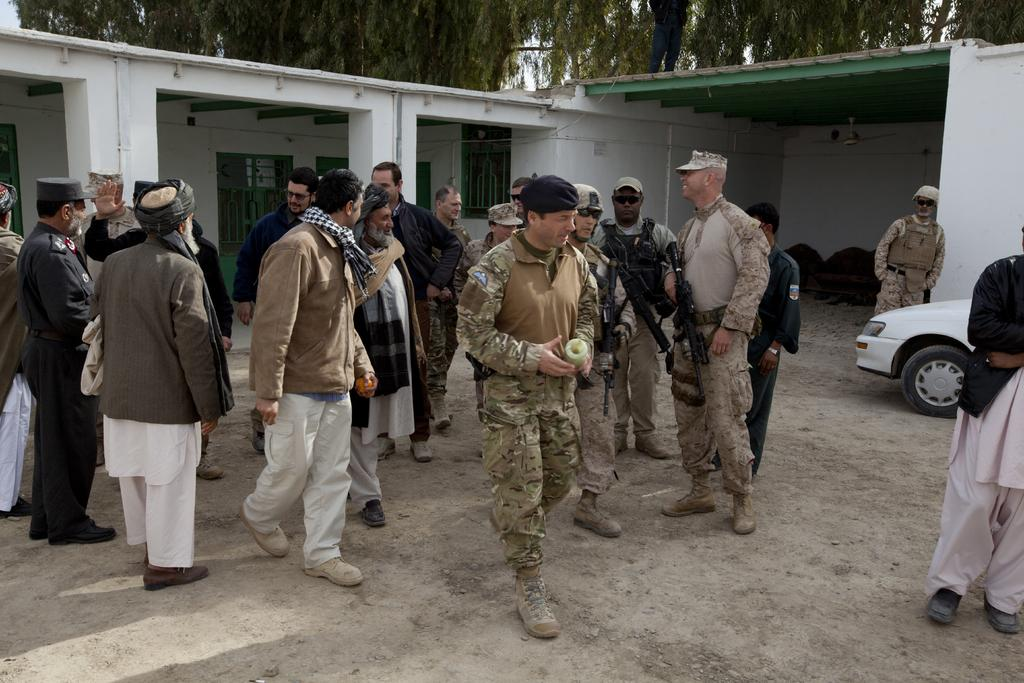What are the men in the image wearing? The men in the image are wearing uniforms. What are some of the men holding in the image? Some of the men are holding weapons. Who else can be seen in the image besides the men in uniforms? There are people in the image. What type of structure is visible in the image? There is a building in the image. What type of natural environment is visible in the image? There are trees in the image, and land is visible. What type of vehicle is present in the image? There is a car in the image. What type of feather can be seen on the car in the image? There is no feather present on the car in the image. What type of camp can be seen in the image? There is no camp present in the image. 